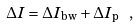<formula> <loc_0><loc_0><loc_500><loc_500>\Delta I = \Delta I _ { \text {bw} } + \Delta I _ { \text {p} } \ ,</formula> 